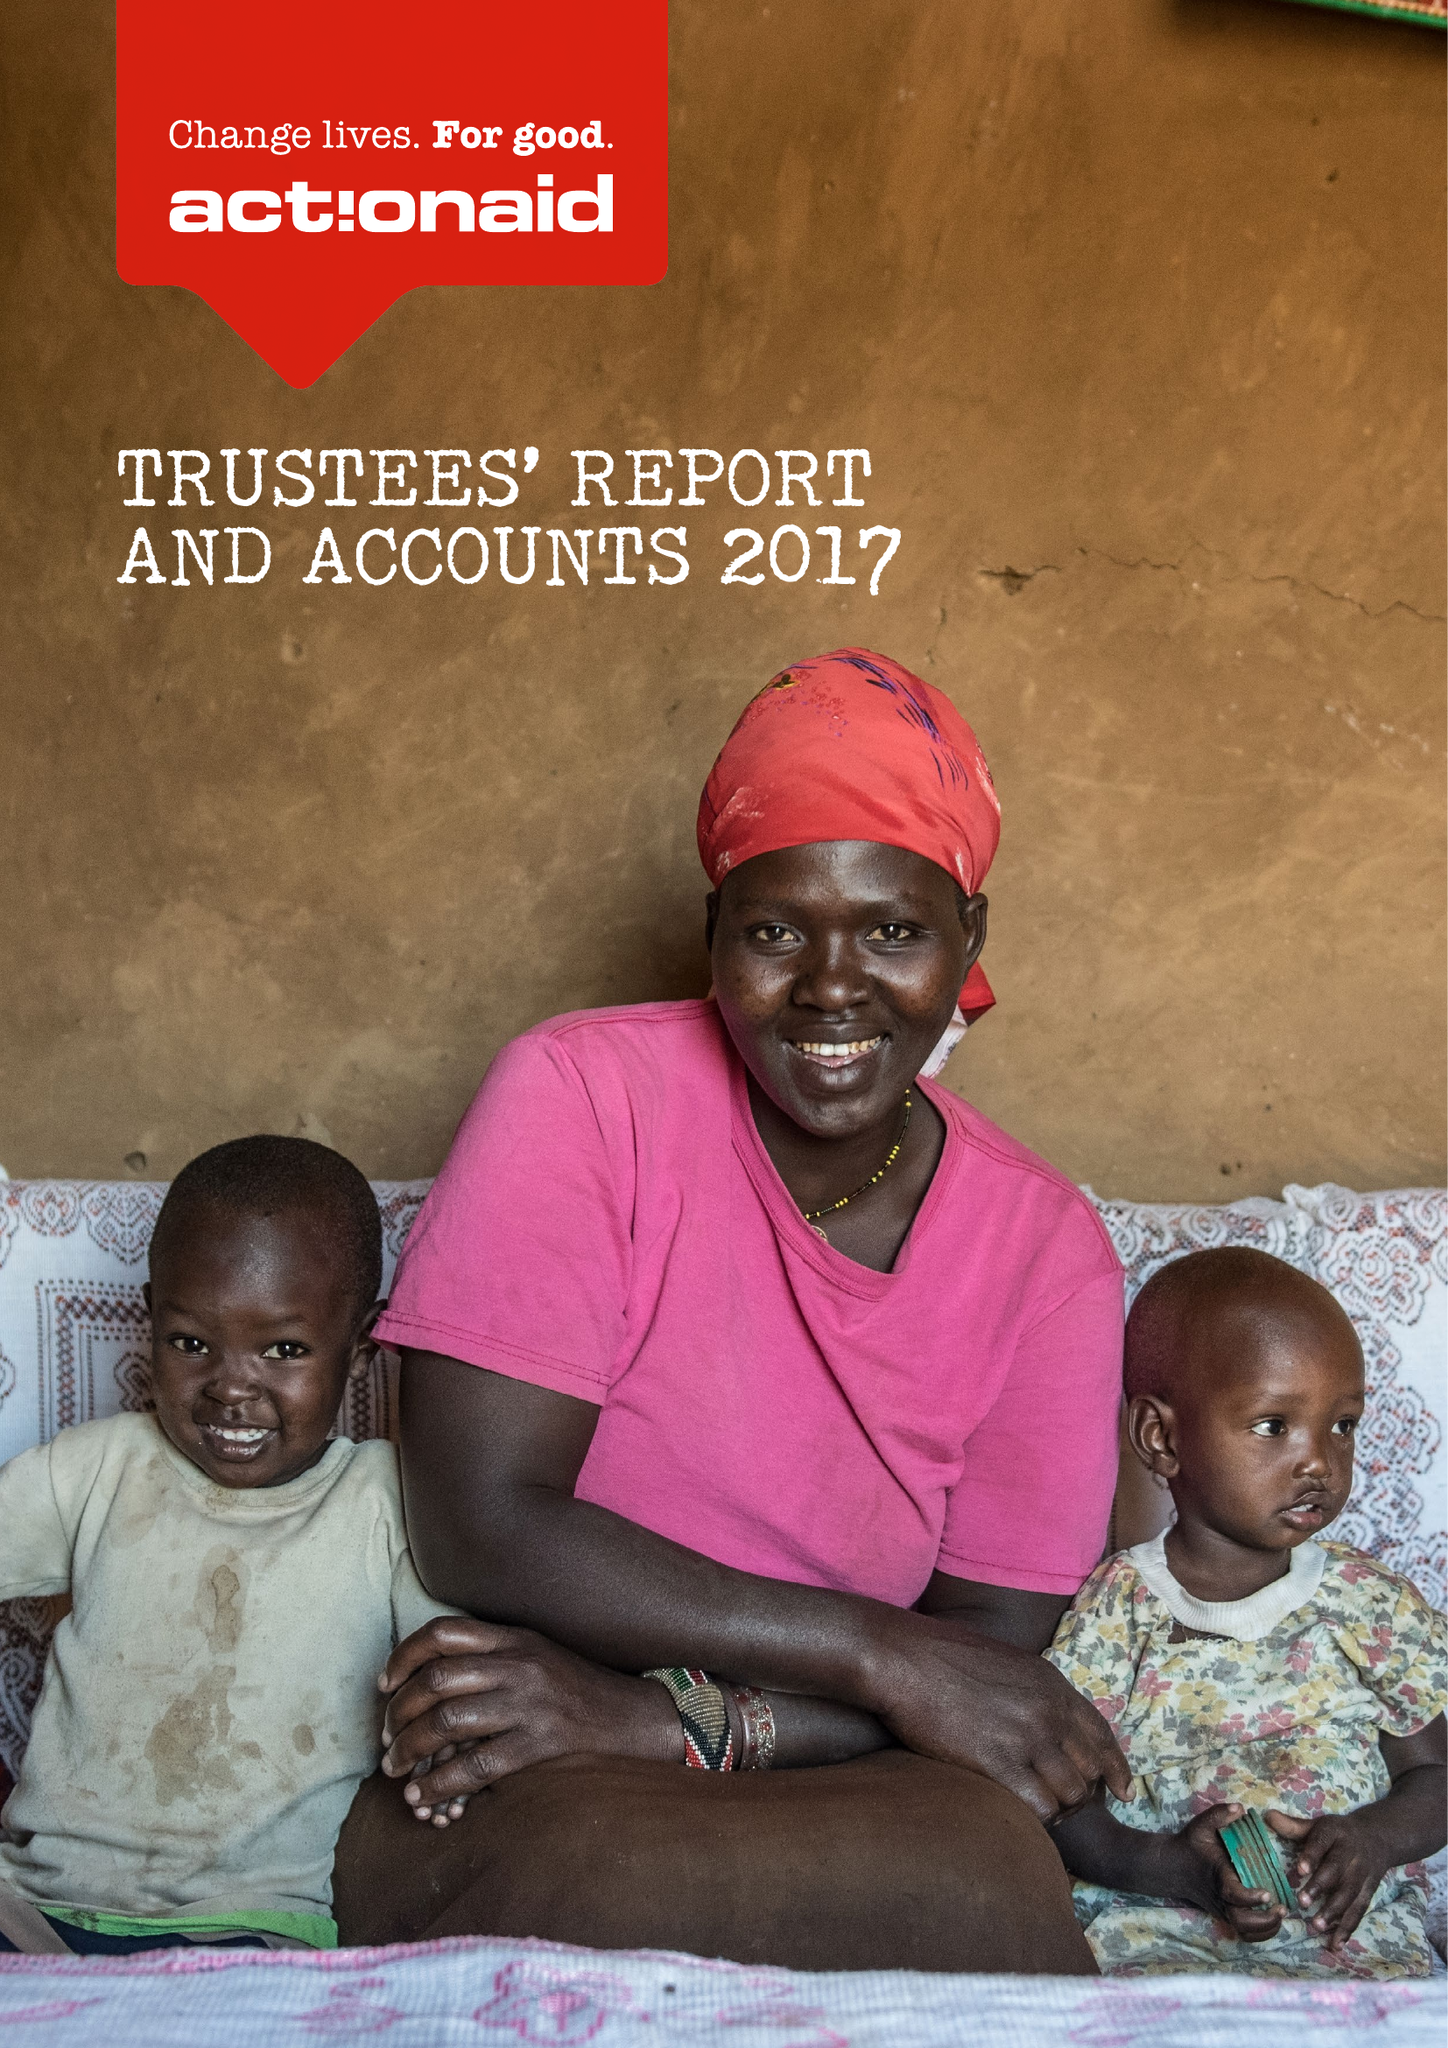What is the value for the spending_annually_in_british_pounds?
Answer the question using a single word or phrase. 60899000.00 